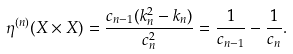<formula> <loc_0><loc_0><loc_500><loc_500>\eta ^ { ( n ) } ( X \times X ) = \frac { c _ { n - 1 } ( k _ { n } ^ { 2 } - k _ { n } ) } { c _ { n } ^ { 2 } } = \frac { 1 } { c _ { n - 1 } } - \frac { 1 } { c _ { n } } .</formula> 